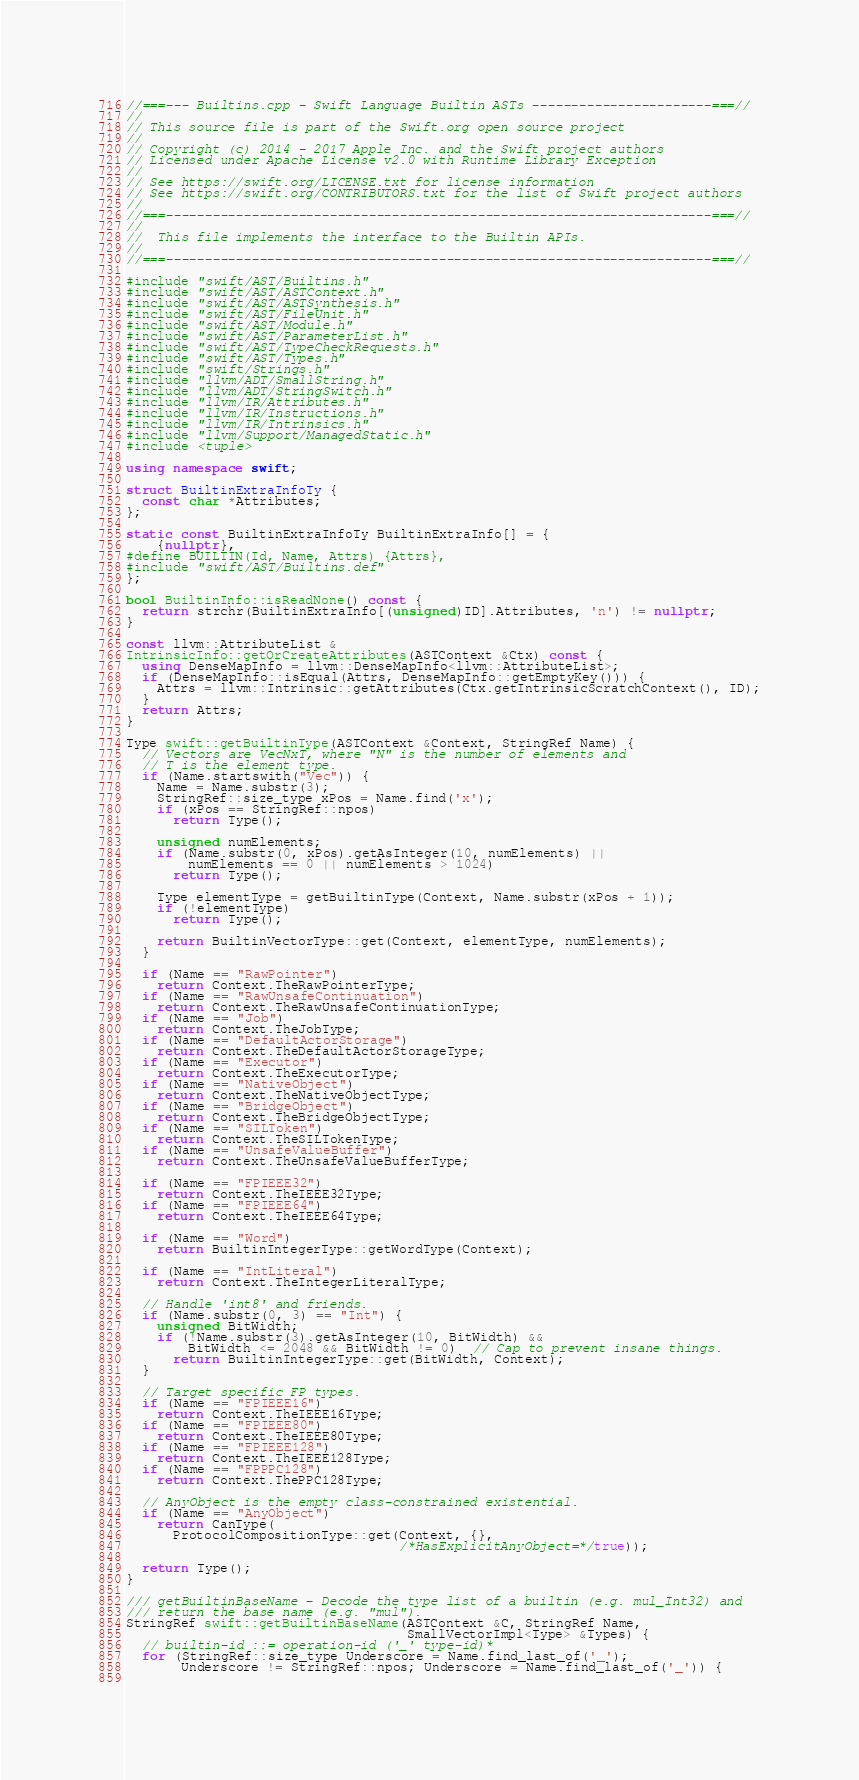<code> <loc_0><loc_0><loc_500><loc_500><_C++_>//===--- Builtins.cpp - Swift Language Builtin ASTs -----------------------===//
//
// This source file is part of the Swift.org open source project
//
// Copyright (c) 2014 - 2017 Apple Inc. and the Swift project authors
// Licensed under Apache License v2.0 with Runtime Library Exception
//
// See https://swift.org/LICENSE.txt for license information
// See https://swift.org/CONTRIBUTORS.txt for the list of Swift project authors
//
//===----------------------------------------------------------------------===//
//
//  This file implements the interface to the Builtin APIs.
//
//===----------------------------------------------------------------------===//

#include "swift/AST/Builtins.h"
#include "swift/AST/ASTContext.h"
#include "swift/AST/ASTSynthesis.h"
#include "swift/AST/FileUnit.h"
#include "swift/AST/Module.h"
#include "swift/AST/ParameterList.h"
#include "swift/AST/TypeCheckRequests.h"
#include "swift/AST/Types.h"
#include "swift/Strings.h"
#include "llvm/ADT/SmallString.h"
#include "llvm/ADT/StringSwitch.h"
#include "llvm/IR/Attributes.h"
#include "llvm/IR/Instructions.h"
#include "llvm/IR/Intrinsics.h"
#include "llvm/Support/ManagedStatic.h"
#include <tuple>

using namespace swift;

struct BuiltinExtraInfoTy {
  const char *Attributes;
};

static const BuiltinExtraInfoTy BuiltinExtraInfo[] = {
    {nullptr},
#define BUILTIN(Id, Name, Attrs) {Attrs},
#include "swift/AST/Builtins.def"
};

bool BuiltinInfo::isReadNone() const {
  return strchr(BuiltinExtraInfo[(unsigned)ID].Attributes, 'n') != nullptr;
}

const llvm::AttributeList &
IntrinsicInfo::getOrCreateAttributes(ASTContext &Ctx) const {
  using DenseMapInfo = llvm::DenseMapInfo<llvm::AttributeList>;
  if (DenseMapInfo::isEqual(Attrs, DenseMapInfo::getEmptyKey())) {
    Attrs = llvm::Intrinsic::getAttributes(Ctx.getIntrinsicScratchContext(), ID);
  }
  return Attrs;
}

Type swift::getBuiltinType(ASTContext &Context, StringRef Name) {
  // Vectors are VecNxT, where "N" is the number of elements and
  // T is the element type.
  if (Name.startswith("Vec")) {
    Name = Name.substr(3);
    StringRef::size_type xPos = Name.find('x');
    if (xPos == StringRef::npos)
      return Type();

    unsigned numElements;
    if (Name.substr(0, xPos).getAsInteger(10, numElements) ||
        numElements == 0 || numElements > 1024)
      return Type();

    Type elementType = getBuiltinType(Context, Name.substr(xPos + 1));
    if (!elementType)
      return Type();

    return BuiltinVectorType::get(Context, elementType, numElements);
  }

  if (Name == "RawPointer")
    return Context.TheRawPointerType;
  if (Name == "RawUnsafeContinuation")
    return Context.TheRawUnsafeContinuationType;
  if (Name == "Job")
    return Context.TheJobType;
  if (Name == "DefaultActorStorage")
    return Context.TheDefaultActorStorageType;
  if (Name == "Executor")
    return Context.TheExecutorType;
  if (Name == "NativeObject")
    return Context.TheNativeObjectType;
  if (Name == "BridgeObject")
    return Context.TheBridgeObjectType;
  if (Name == "SILToken")
    return Context.TheSILTokenType;
  if (Name == "UnsafeValueBuffer")
    return Context.TheUnsafeValueBufferType;
  
  if (Name == "FPIEEE32")
    return Context.TheIEEE32Type;
  if (Name == "FPIEEE64")
    return Context.TheIEEE64Type;

  if (Name == "Word")
    return BuiltinIntegerType::getWordType(Context);

  if (Name == "IntLiteral")
    return Context.TheIntegerLiteralType;

  // Handle 'int8' and friends.
  if (Name.substr(0, 3) == "Int") {
    unsigned BitWidth;
    if (!Name.substr(3).getAsInteger(10, BitWidth) &&
        BitWidth <= 2048 && BitWidth != 0)  // Cap to prevent insane things.
      return BuiltinIntegerType::get(BitWidth, Context);
  }
  
  // Target specific FP types.
  if (Name == "FPIEEE16")
    return Context.TheIEEE16Type;
  if (Name == "FPIEEE80")
    return Context.TheIEEE80Type;
  if (Name == "FPIEEE128")
    return Context.TheIEEE128Type;
  if (Name == "FPPPC128")
    return Context.ThePPC128Type;

  // AnyObject is the empty class-constrained existential.
  if (Name == "AnyObject")
    return CanType(
      ProtocolCompositionType::get(Context, {},
                                   /*HasExplicitAnyObject=*/true));

  return Type();
}

/// getBuiltinBaseName - Decode the type list of a builtin (e.g. mul_Int32) and
/// return the base name (e.g. "mul").
StringRef swift::getBuiltinBaseName(ASTContext &C, StringRef Name,
                                    SmallVectorImpl<Type> &Types) {
  // builtin-id ::= operation-id ('_' type-id)*
  for (StringRef::size_type Underscore = Name.find_last_of('_');
       Underscore != StringRef::npos; Underscore = Name.find_last_of('_')) {
    </code> 